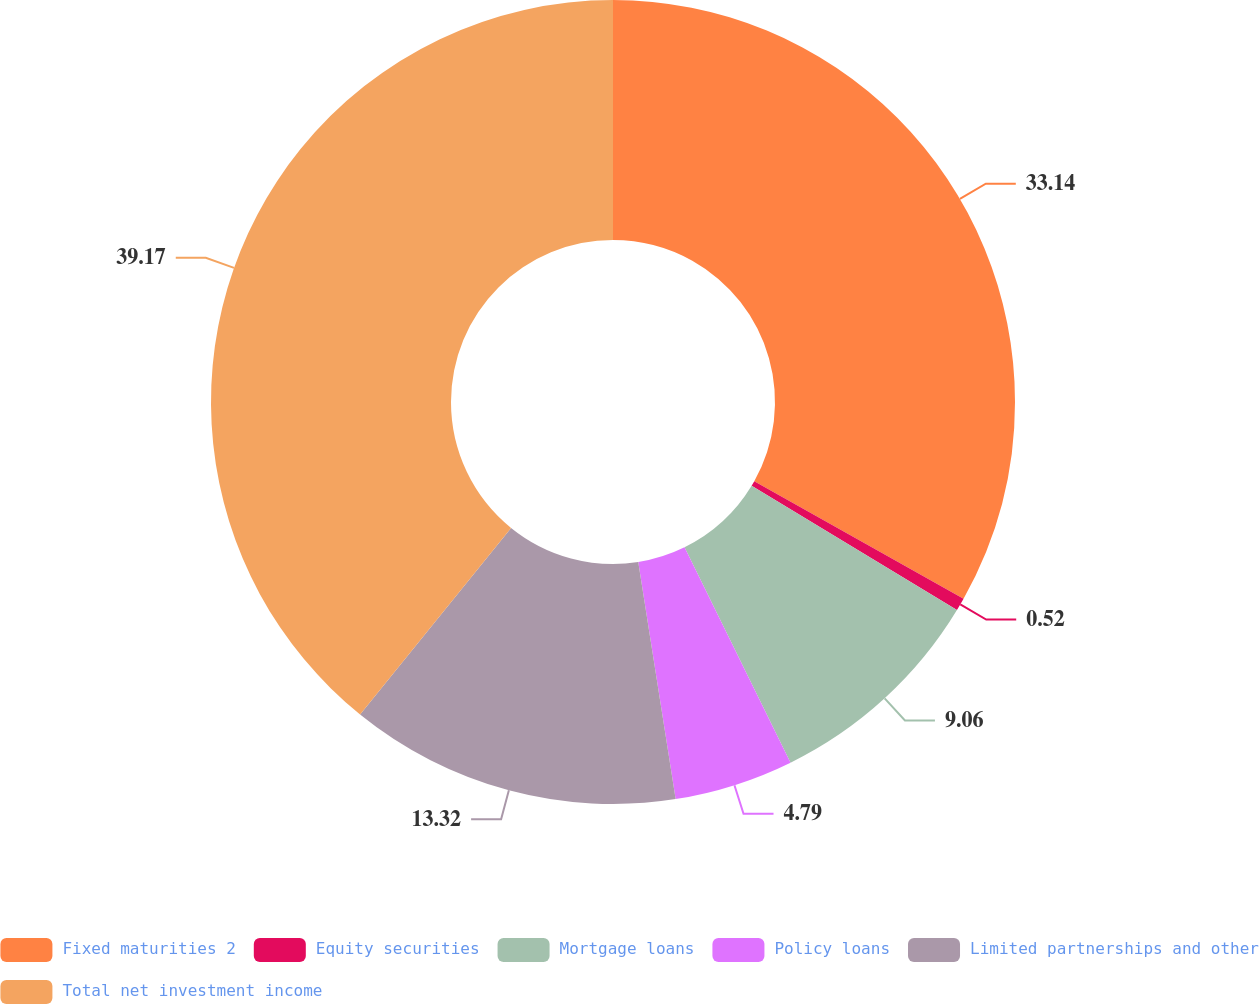<chart> <loc_0><loc_0><loc_500><loc_500><pie_chart><fcel>Fixed maturities 2<fcel>Equity securities<fcel>Mortgage loans<fcel>Policy loans<fcel>Limited partnerships and other<fcel>Total net investment income<nl><fcel>33.14%<fcel>0.52%<fcel>9.06%<fcel>4.79%<fcel>13.32%<fcel>39.17%<nl></chart> 